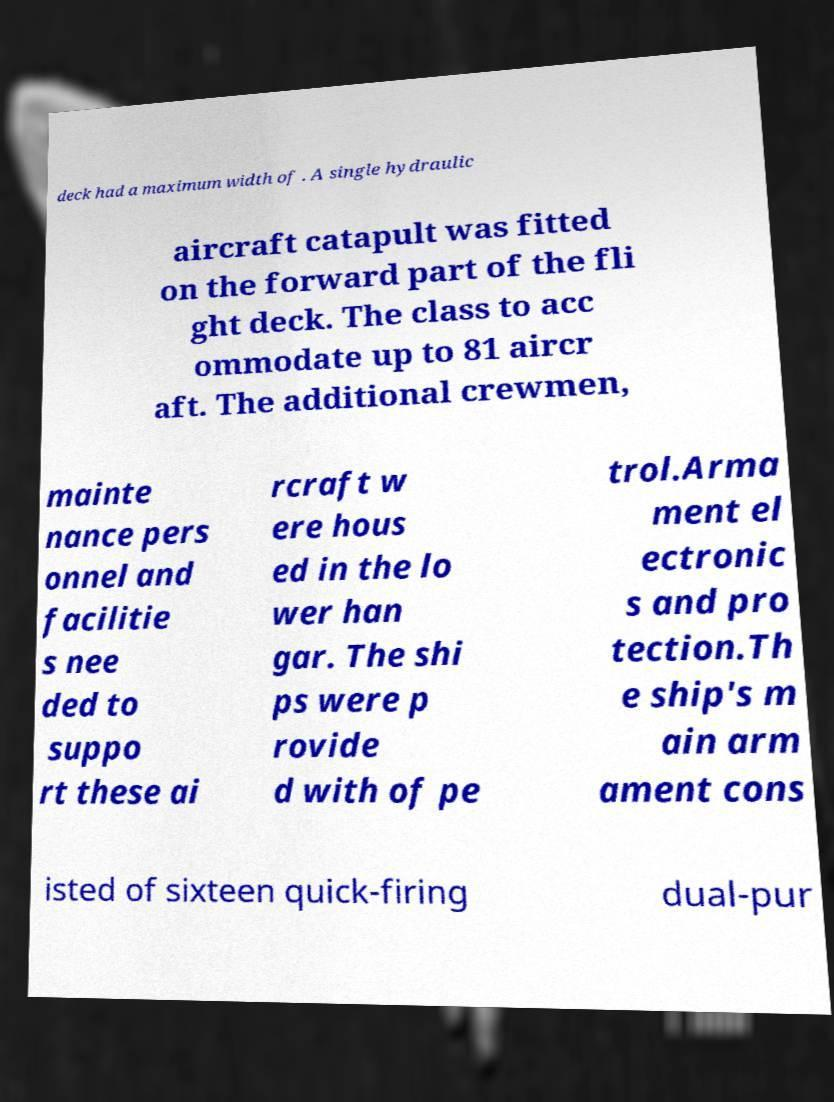Could you extract and type out the text from this image? deck had a maximum width of . A single hydraulic aircraft catapult was fitted on the forward part of the fli ght deck. The class to acc ommodate up to 81 aircr aft. The additional crewmen, mainte nance pers onnel and facilitie s nee ded to suppo rt these ai rcraft w ere hous ed in the lo wer han gar. The shi ps were p rovide d with of pe trol.Arma ment el ectronic s and pro tection.Th e ship's m ain arm ament cons isted of sixteen quick-firing dual-pur 